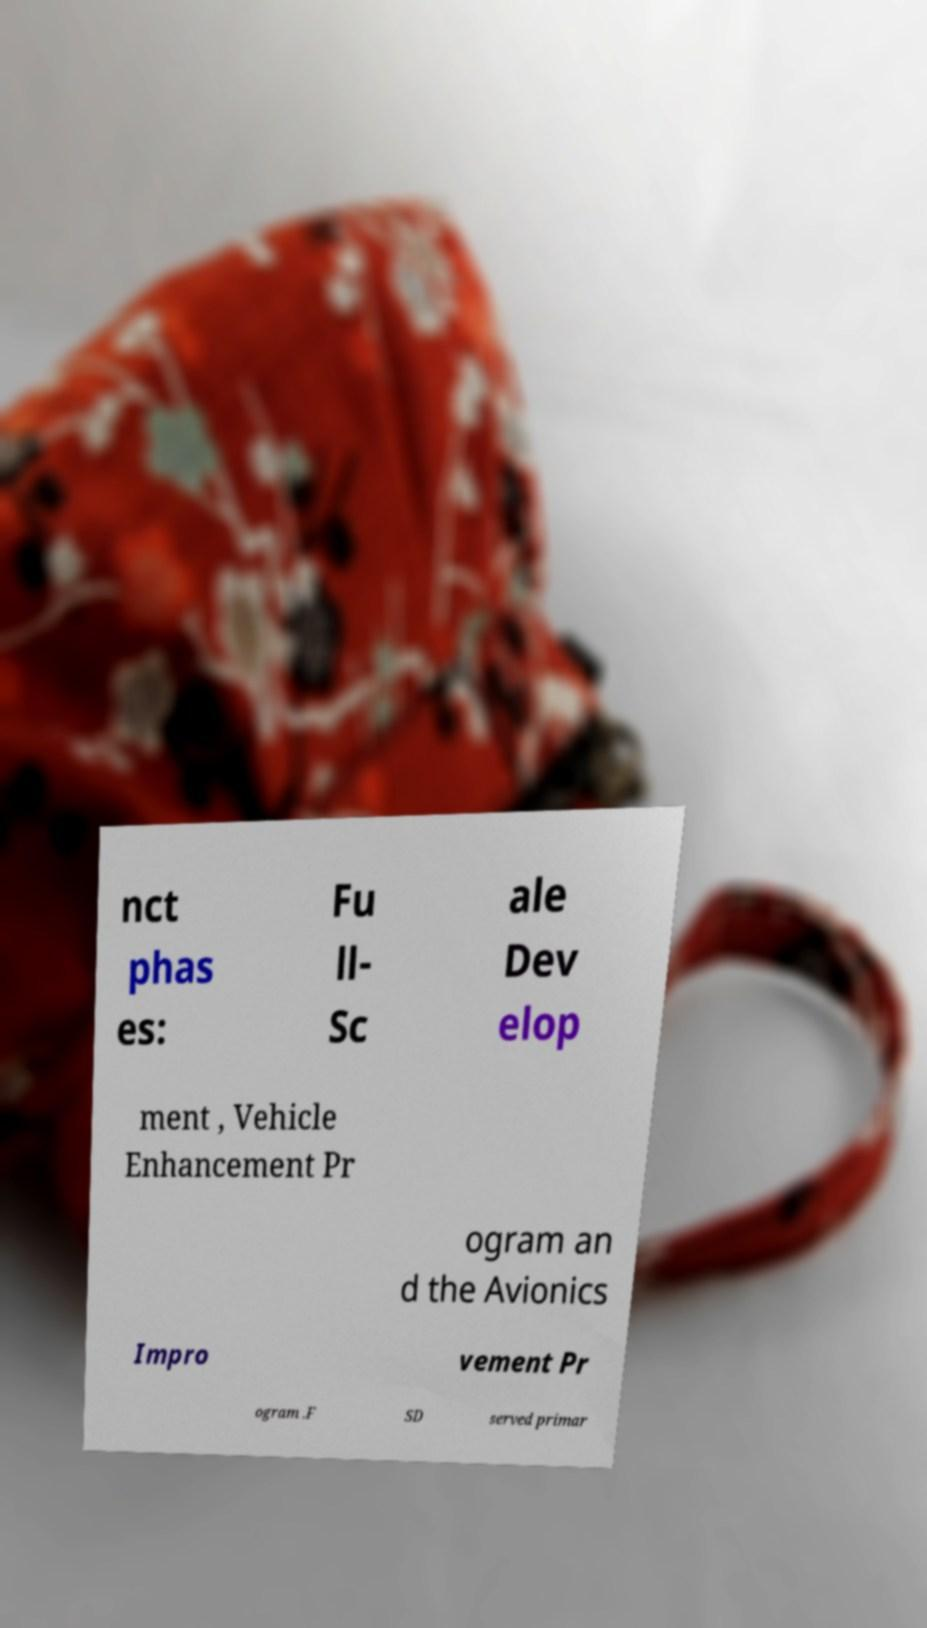Can you read and provide the text displayed in the image?This photo seems to have some interesting text. Can you extract and type it out for me? nct phas es: Fu ll- Sc ale Dev elop ment , Vehicle Enhancement Pr ogram an d the Avionics Impro vement Pr ogram .F SD served primar 